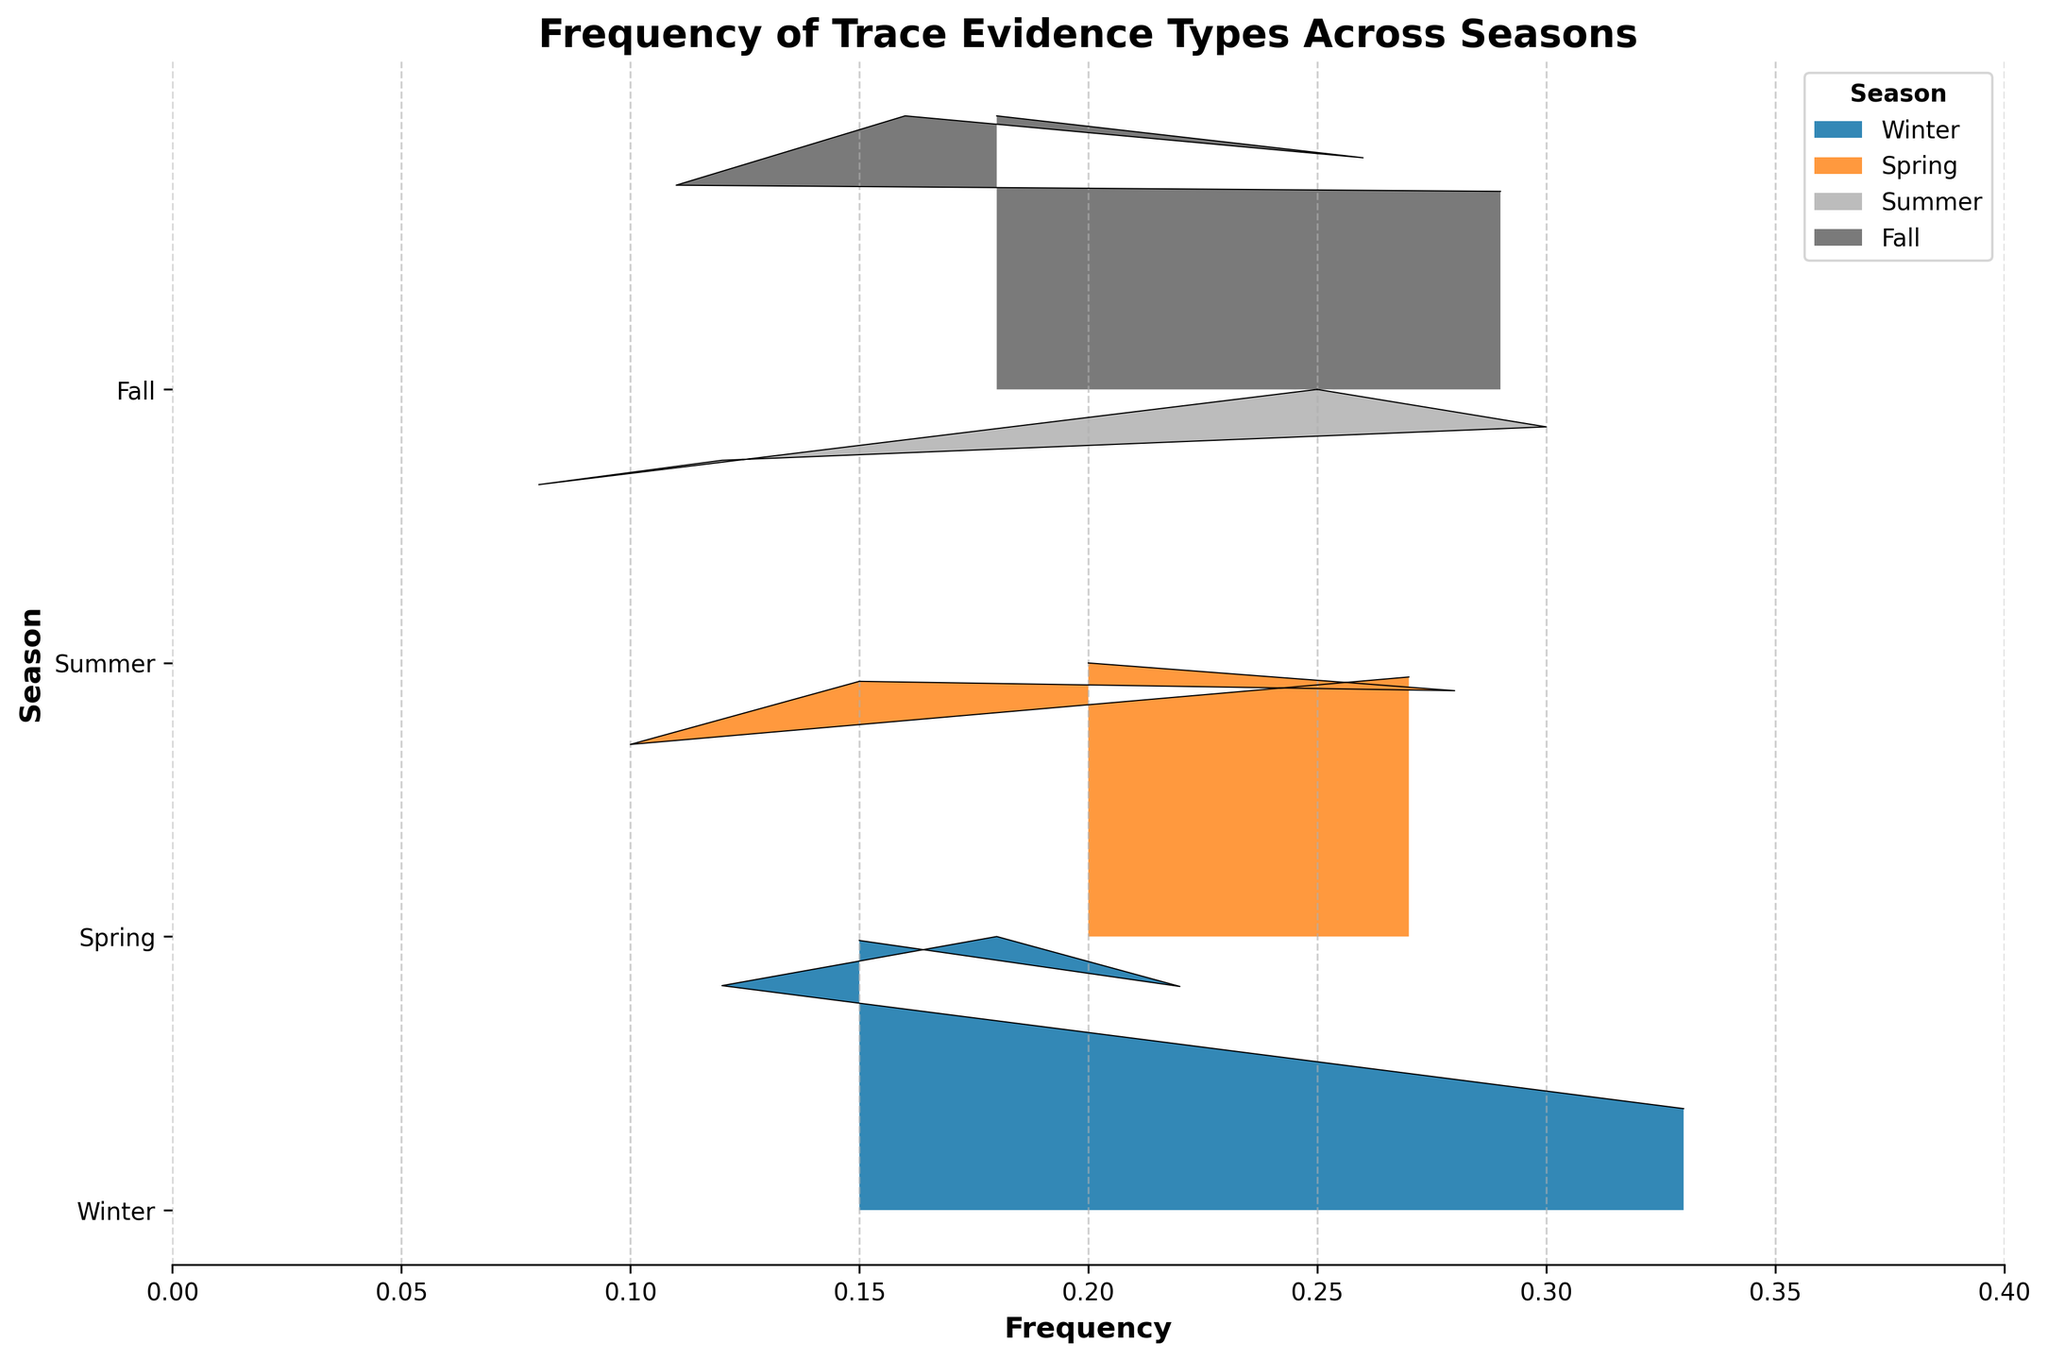what is the title of the plot? The title is usually positioned at the top of the plot and is clearly labeled. Here it's "Frequency of Trace Evidence Types Across Seasons".
Answer: Frequency of Trace Evidence Types Across Seasons What season has the highest peak for "Hair fibers"? The ridgeline plot likely shows multiple lines for each season, and each peak represents the highest frequency observed. Among the seasons, Summer shows the highest peak for "Hair fibers".
Answer: Summer What are the x-axis and y-axis labels? The x-axis and y-axis labels are positioned beside their respective axes. The x-axis label is "Frequency", and the y-axis label is "Season".
Answer: Frequency; Season Which evidence type has the highest overall frequency across all seasons? Inspecting the peaks for all evidence types across the seasons, "Fabric fibers" have the highest overall frequency, especially in Winter.
Answer: Fabric fibers In which season does "Glass shards" have its least frequency? By examining the ridgelines for "Glass shards" across all seasons, Summer shows the least frequency.
Answer: Summer Are there any evidence types consistently found across all seasons? The evidence types like Hair fibers, Soil particles, Glass shards, Paint chips, and Fabric fibers are present, as they recur in each season’s peak.
Answer: Yes Which evidence type has the lowest frequency in Spring? By comparing the frequencies of all evidence types in Spring, "Paint chips" has the lowest frequency.
Answer: Paint chips How does the frequency distribution of "Soil particles" compare between Winter and Fall? In Winter, the peak of "Soil particles" is slightly higher than in Fall, indicating a higher frequency. Comparing both seasons shows Winter has a higher frequency for "Soil particles".
Answer: Winter has a higher frequency Which season shows the most variance in the frequency of its evidence types? By observing the spread and height of the peaks, Winter shows the most variance with a wider range of frequencies for different evidence types.
Answer: Winter For "Fabric fibers", which two seasons have the closest frequency? By comparing the peaks of each relevant season, Spring and Summer have the closest frequency for "Fabric fibers".
Answer: Spring and Summer 